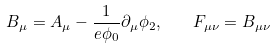<formula> <loc_0><loc_0><loc_500><loc_500>B _ { \mu } = A _ { \mu } - \frac { 1 } { e \phi _ { 0 } } \partial _ { \mu } \phi _ { 2 } , \quad F _ { \mu \nu } = B _ { \mu \nu }</formula> 